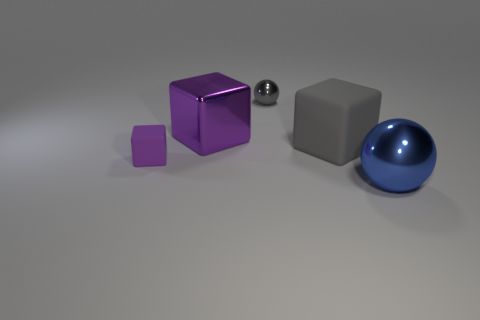Add 1 small things. How many objects exist? 6 Subtract all blocks. How many objects are left? 2 Add 4 blue shiny spheres. How many blue shiny spheres exist? 5 Subtract 0 cyan balls. How many objects are left? 5 Subtract all gray shiny balls. Subtract all big shiny objects. How many objects are left? 2 Add 4 tiny gray metal balls. How many tiny gray metal balls are left? 5 